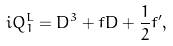<formula> <loc_0><loc_0><loc_500><loc_500>i Q _ { 1 } ^ { L } = D ^ { 3 } + f D + \frac { 1 } { 2 } f ^ { \prime } ,</formula> 